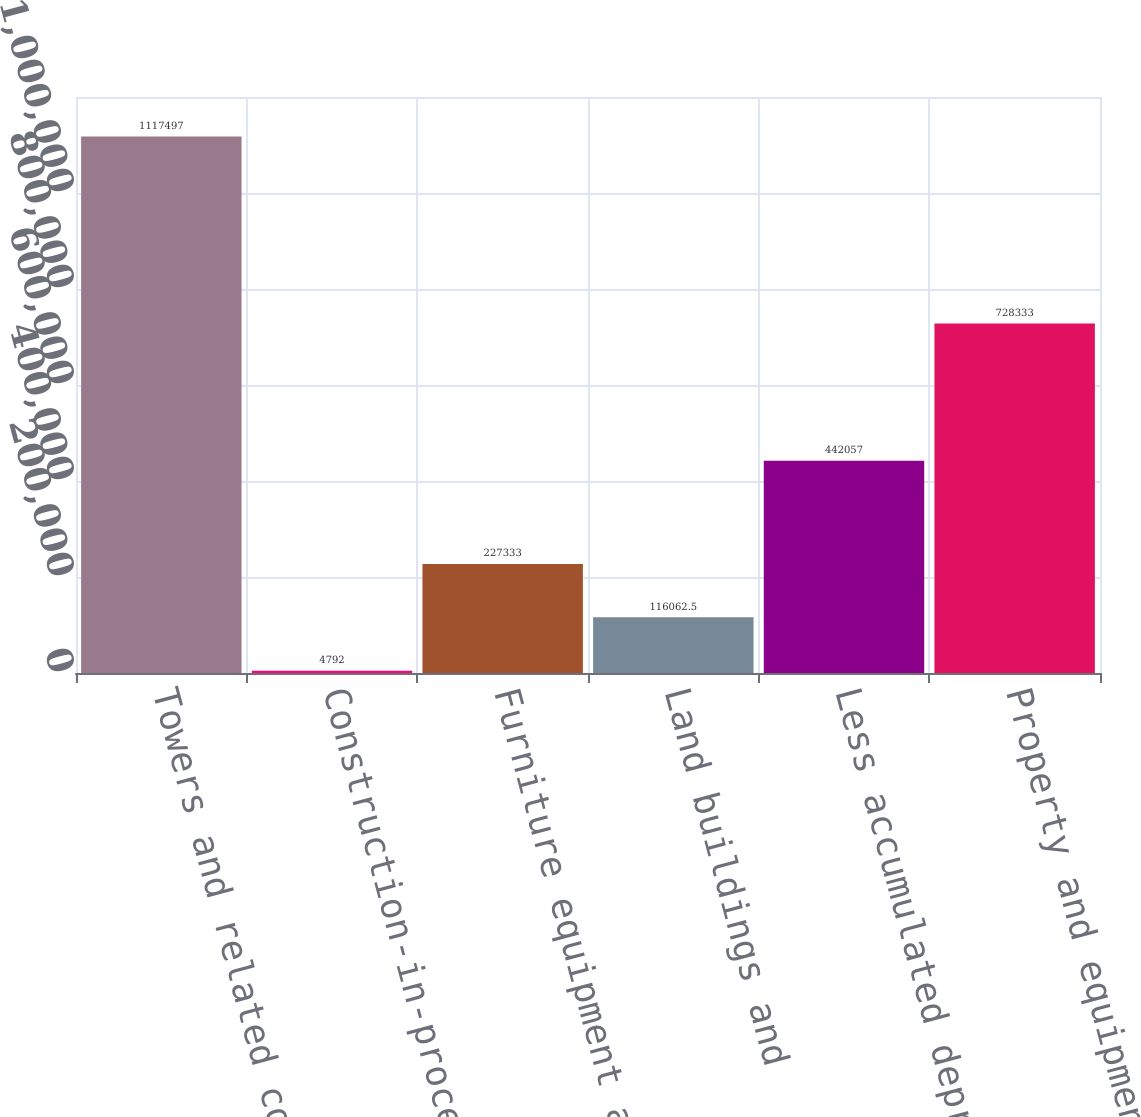Convert chart. <chart><loc_0><loc_0><loc_500><loc_500><bar_chart><fcel>Towers and related components<fcel>Construction-in-process<fcel>Furniture equipment and<fcel>Land buildings and<fcel>Less accumulated depreciation<fcel>Property and equipment net<nl><fcel>1.1175e+06<fcel>4792<fcel>227333<fcel>116062<fcel>442057<fcel>728333<nl></chart> 